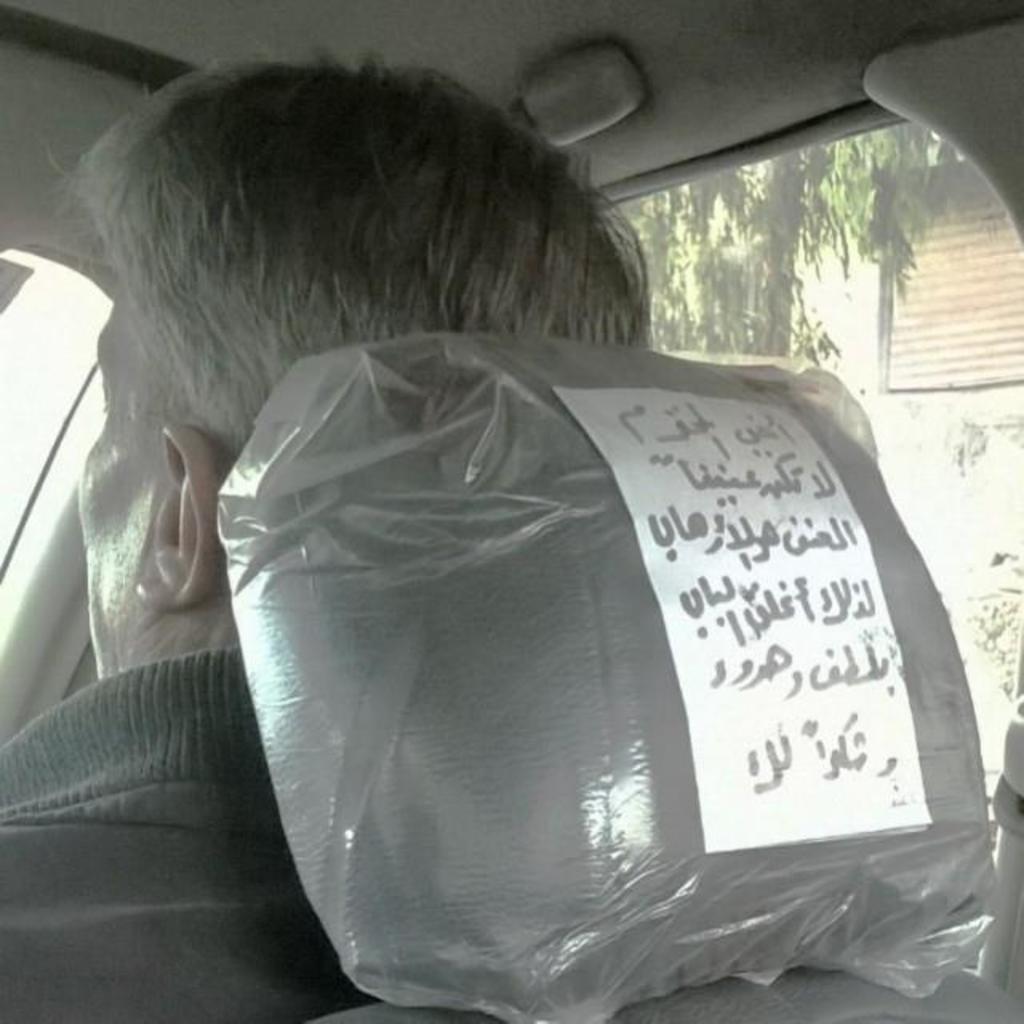How would you summarize this image in a sentence or two? This picture seems to be clicked inside the vehicle. On the right we can see the text on the paper attached to the seat and we can see a person sitting. In the background we can see the tree and the wall of the building and some other objects. 